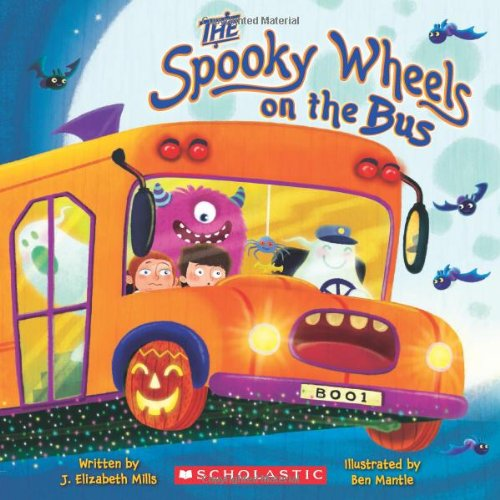Who wrote this book? The book 'The Spooky Wheels on the Bus' was written by J. Elizabeth Mills. 